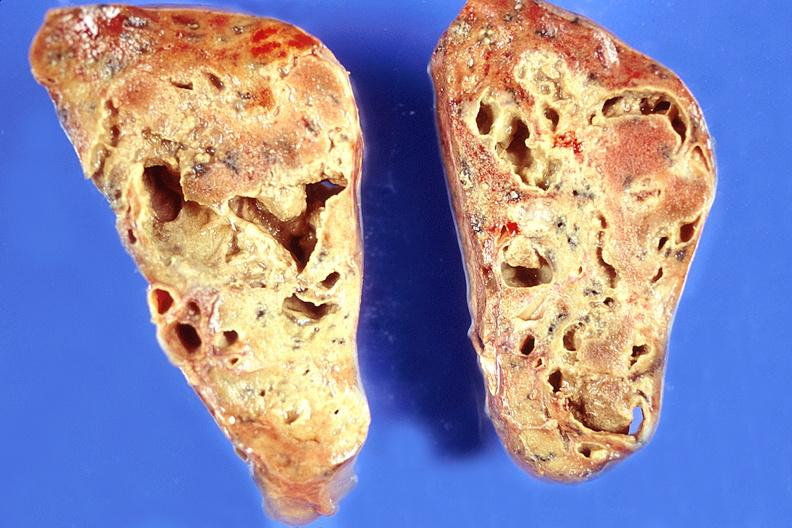does cytomegaly show lung, chronic abscesses?
Answer the question using a single word or phrase. No 